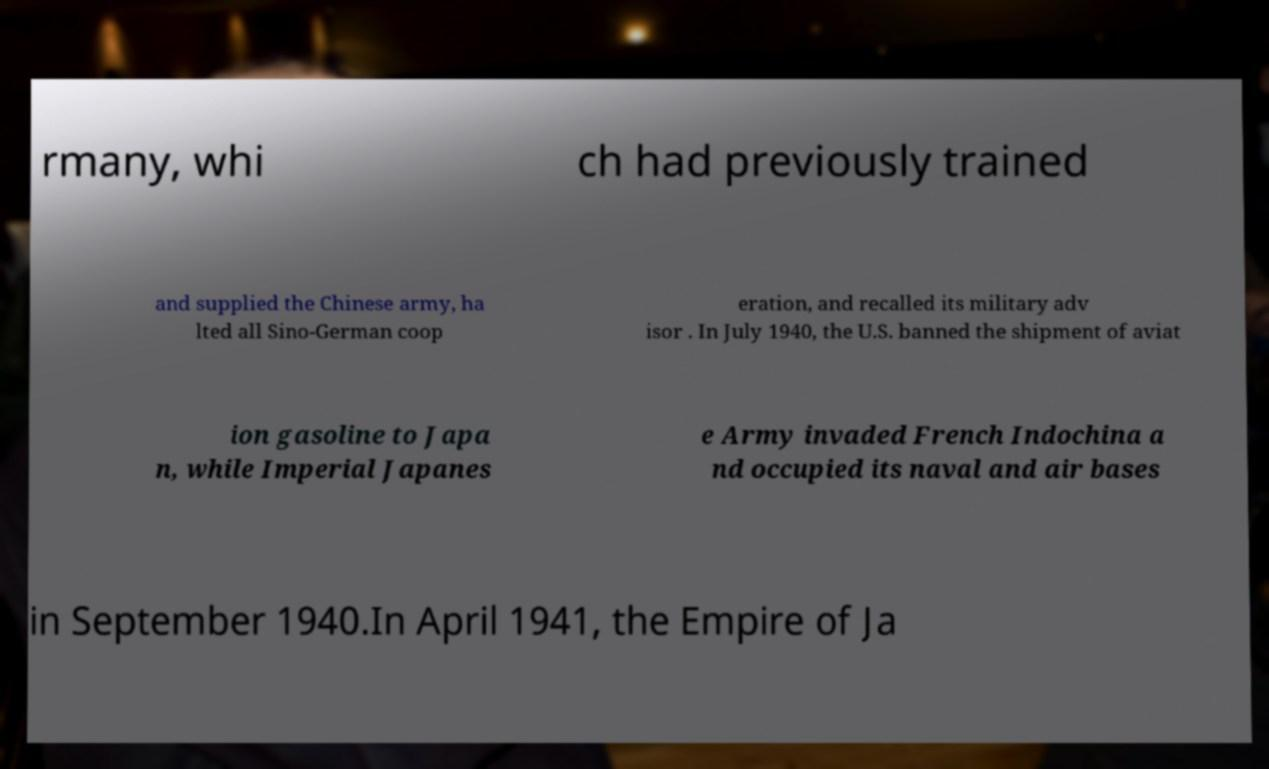Please read and relay the text visible in this image. What does it say? rmany, whi ch had previously trained and supplied the Chinese army, ha lted all Sino-German coop eration, and recalled its military adv isor . In July 1940, the U.S. banned the shipment of aviat ion gasoline to Japa n, while Imperial Japanes e Army invaded French Indochina a nd occupied its naval and air bases in September 1940.In April 1941, the Empire of Ja 